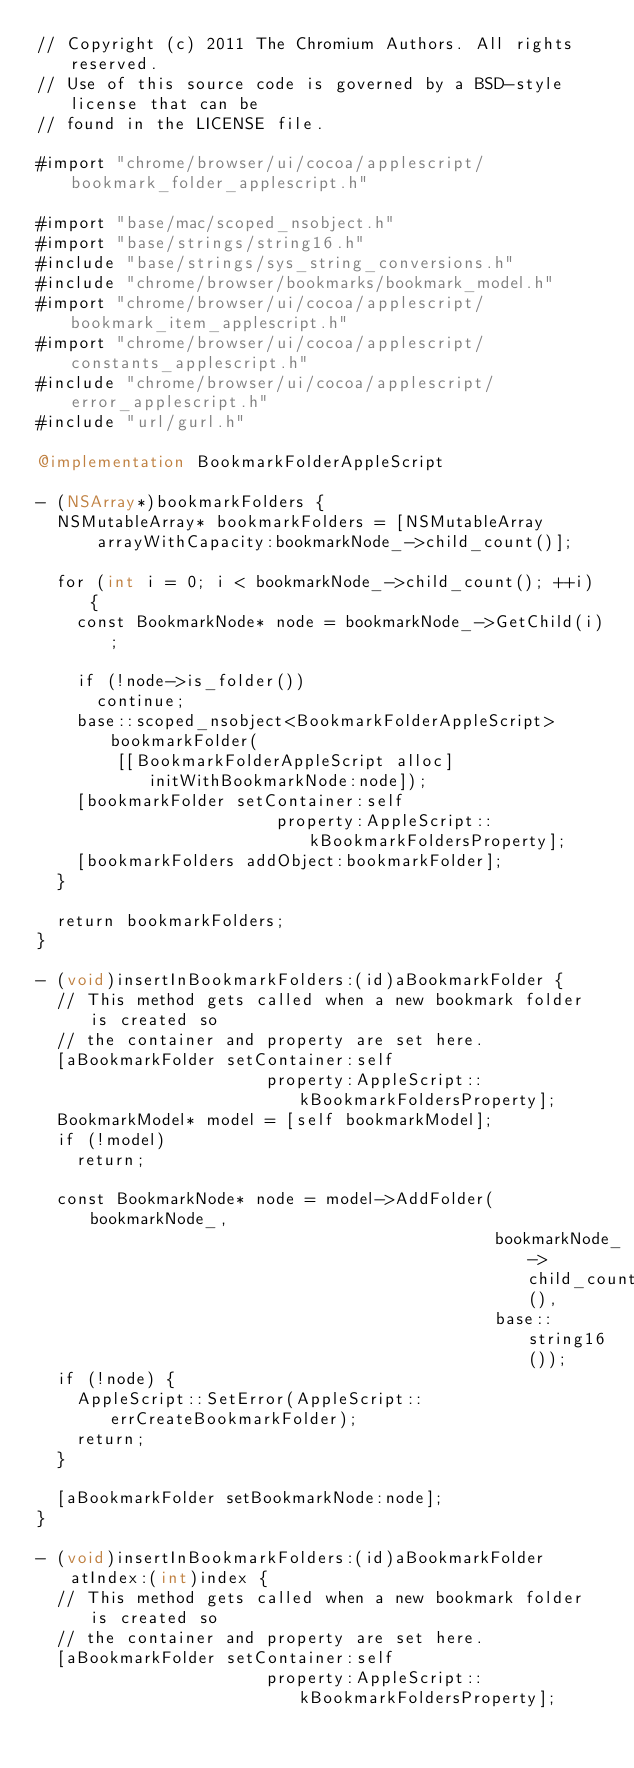Convert code to text. <code><loc_0><loc_0><loc_500><loc_500><_ObjectiveC_>// Copyright (c) 2011 The Chromium Authors. All rights reserved.
// Use of this source code is governed by a BSD-style license that can be
// found in the LICENSE file.

#import "chrome/browser/ui/cocoa/applescript/bookmark_folder_applescript.h"

#import "base/mac/scoped_nsobject.h"
#import "base/strings/string16.h"
#include "base/strings/sys_string_conversions.h"
#include "chrome/browser/bookmarks/bookmark_model.h"
#import "chrome/browser/ui/cocoa/applescript/bookmark_item_applescript.h"
#import "chrome/browser/ui/cocoa/applescript/constants_applescript.h"
#include "chrome/browser/ui/cocoa/applescript/error_applescript.h"
#include "url/gurl.h"

@implementation BookmarkFolderAppleScript

- (NSArray*)bookmarkFolders {
  NSMutableArray* bookmarkFolders = [NSMutableArray
      arrayWithCapacity:bookmarkNode_->child_count()];

  for (int i = 0; i < bookmarkNode_->child_count(); ++i) {
    const BookmarkNode* node = bookmarkNode_->GetChild(i);

    if (!node->is_folder())
      continue;
    base::scoped_nsobject<BookmarkFolderAppleScript> bookmarkFolder(
        [[BookmarkFolderAppleScript alloc] initWithBookmarkNode:node]);
    [bookmarkFolder setContainer:self
                        property:AppleScript::kBookmarkFoldersProperty];
    [bookmarkFolders addObject:bookmarkFolder];
  }

  return bookmarkFolders;
}

- (void)insertInBookmarkFolders:(id)aBookmarkFolder {
  // This method gets called when a new bookmark folder is created so
  // the container and property are set here.
  [aBookmarkFolder setContainer:self
                       property:AppleScript::kBookmarkFoldersProperty];
  BookmarkModel* model = [self bookmarkModel];
  if (!model)
    return;

  const BookmarkNode* node = model->AddFolder(bookmarkNode_,
                                              bookmarkNode_->child_count(),
                                              base::string16());
  if (!node) {
    AppleScript::SetError(AppleScript::errCreateBookmarkFolder);
    return;
  }

  [aBookmarkFolder setBookmarkNode:node];
}

- (void)insertInBookmarkFolders:(id)aBookmarkFolder atIndex:(int)index {
  // This method gets called when a new bookmark folder is created so
  // the container and property are set here.
  [aBookmarkFolder setContainer:self
                       property:AppleScript::kBookmarkFoldersProperty];</code> 